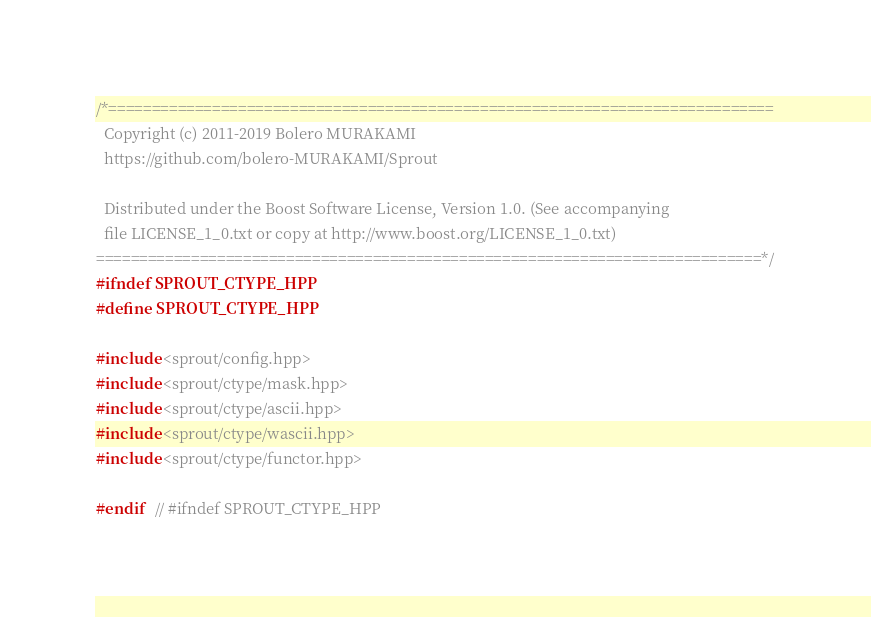<code> <loc_0><loc_0><loc_500><loc_500><_C++_>/*=============================================================================
  Copyright (c) 2011-2019 Bolero MURAKAMI
  https://github.com/bolero-MURAKAMI/Sprout

  Distributed under the Boost Software License, Version 1.0. (See accompanying
  file LICENSE_1_0.txt or copy at http://www.boost.org/LICENSE_1_0.txt)
=============================================================================*/
#ifndef SPROUT_CTYPE_HPP
#define SPROUT_CTYPE_HPP

#include <sprout/config.hpp>
#include <sprout/ctype/mask.hpp>
#include <sprout/ctype/ascii.hpp>
#include <sprout/ctype/wascii.hpp>
#include <sprout/ctype/functor.hpp>

#endif	// #ifndef SPROUT_CTYPE_HPP
</code> 